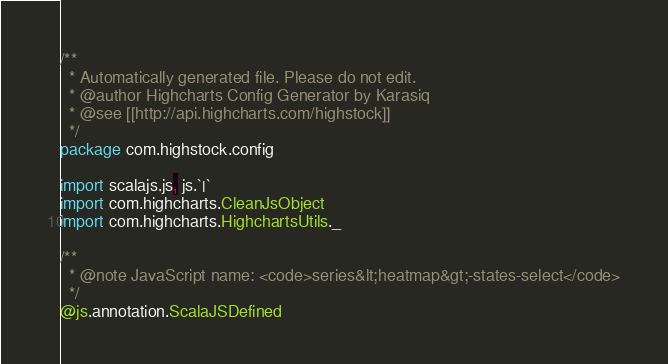<code> <loc_0><loc_0><loc_500><loc_500><_Scala_>/**
  * Automatically generated file. Please do not edit.
  * @author Highcharts Config Generator by Karasiq
  * @see [[http://api.highcharts.com/highstock]]
  */
package com.highstock.config

import scalajs.js, js.`|`
import com.highcharts.CleanJsObject
import com.highcharts.HighchartsUtils._

/**
  * @note JavaScript name: <code>series&lt;heatmap&gt;-states-select</code>
  */
@js.annotation.ScalaJSDefined</code> 